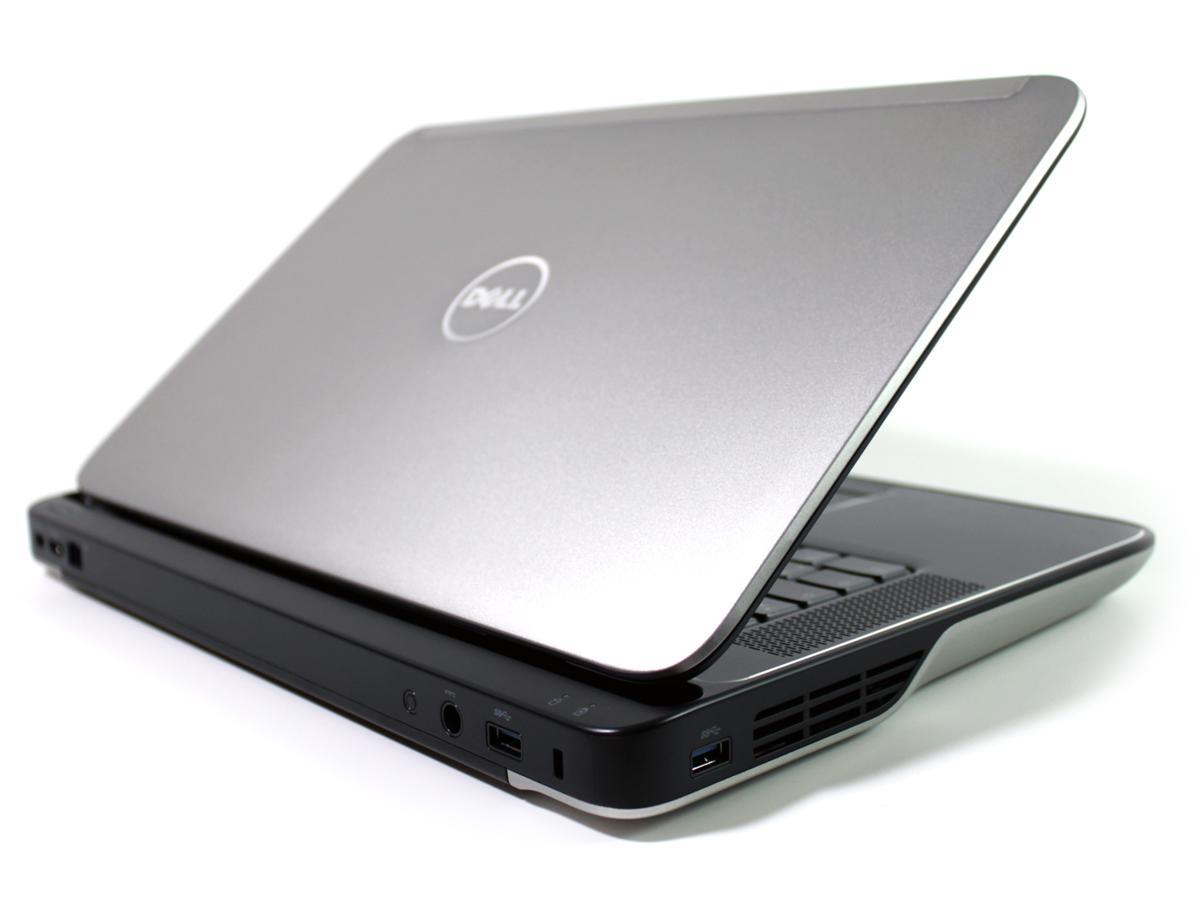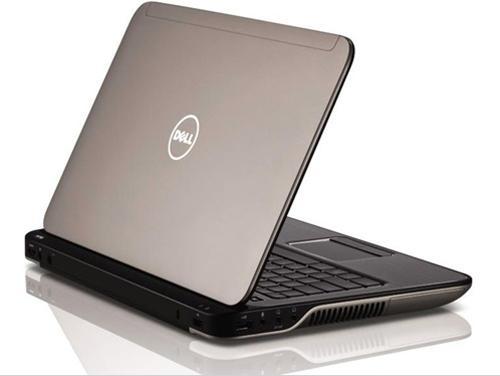The first image is the image on the left, the second image is the image on the right. Given the left and right images, does the statement "The computer screen is visible in at least one of the images." hold true? Answer yes or no. No. The first image is the image on the left, the second image is the image on the right. For the images shown, is this caption "Each image contains only one laptop, and all laptops are open at less than a 90-degree angle and facing the same general direction." true? Answer yes or no. Yes. 